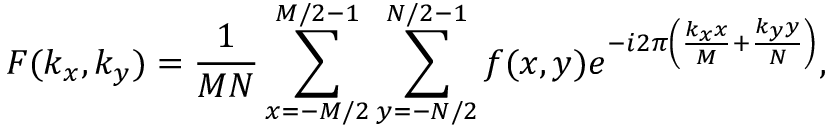<formula> <loc_0><loc_0><loc_500><loc_500>F ( k _ { x } , k _ { y } ) = \frac { 1 } { M N } \sum _ { x = - M / 2 } ^ { M / 2 - 1 } \sum _ { y = - N / 2 } ^ { N / 2 - 1 } f ( x , y ) e ^ { - i 2 \pi \left ( \frac { k _ { x } x } { M } + \frac { k _ { y } y } { N } \right ) } ,</formula> 